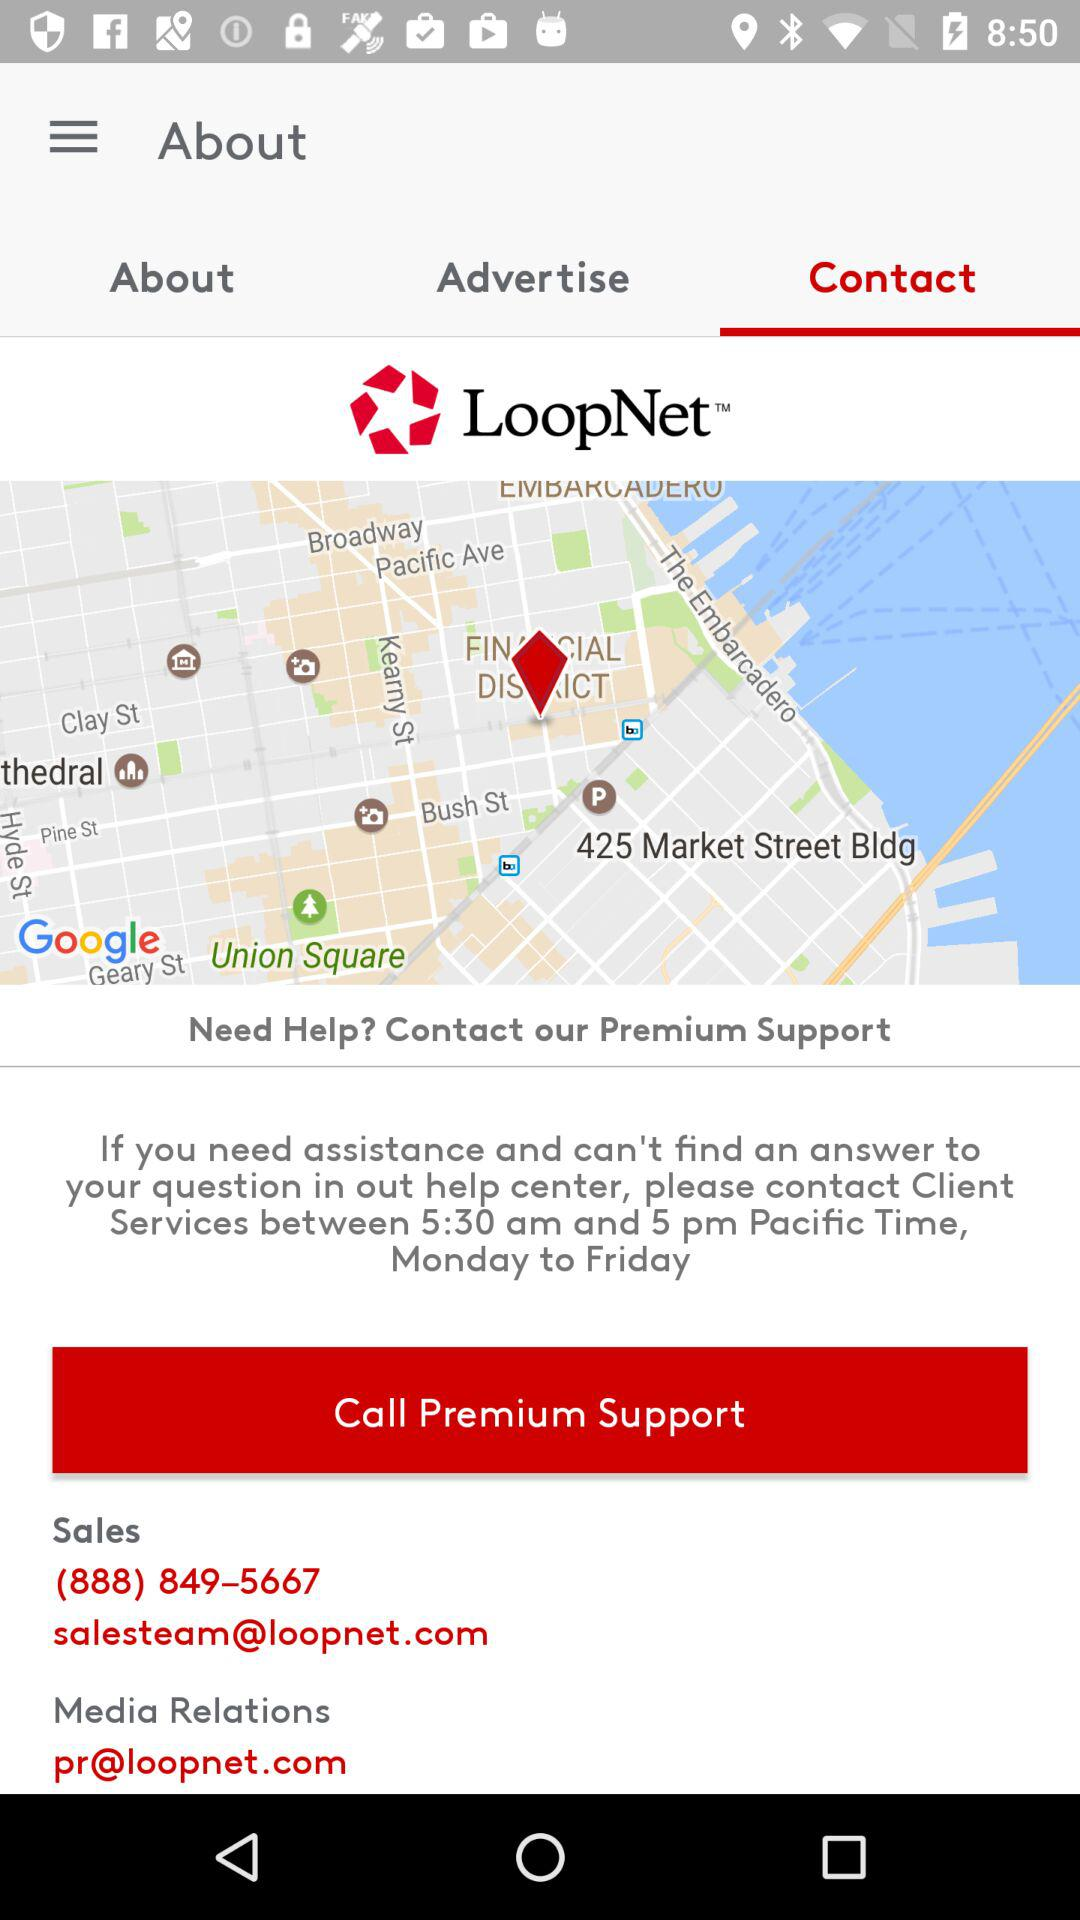What is the email address for media relations? The email address is pr@loopnet.com. 